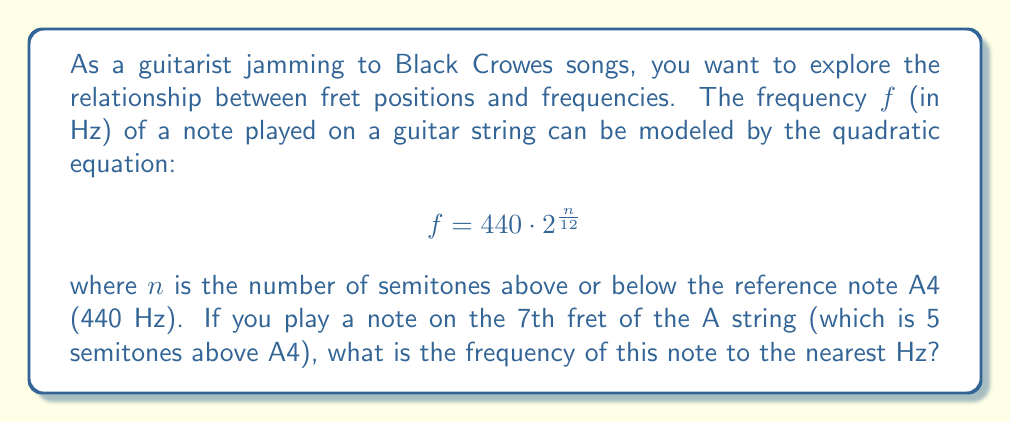Show me your answer to this math problem. Let's approach this step-by-step:

1) We are given the quadratic equation for frequency:
   $$ f = 440 \cdot 2^{\frac{n}{12}} $$

2) We need to find $n$, which is the number of semitones above A4.
   - The A string is tuned to A3, which is 12 semitones below A4.
   - The 7th fret is 7 semitones above the open string.
   - So, $n = -12 + 7 = -5$ semitones from A4.

3) Now we can substitute $n = -5$ into our equation:
   $$ f = 440 \cdot 2^{\frac{-5}{12}} $$

4) Let's calculate this step-by-step:
   $$ f = 440 \cdot (2^{-\frac{5}{12}}) $$
   $$ f = 440 \cdot (\frac{1}{2^{\frac{5}{12}}}) $$
   $$ f = 440 \cdot 0.749153538438 $$
   $$ f = 329.627556913 $$

5) Rounding to the nearest Hz:
   $$ f \approx 330 \text{ Hz} $$

This frequency corresponds to the note E4, which is indeed 5 semitones below A4.
Answer: 330 Hz 